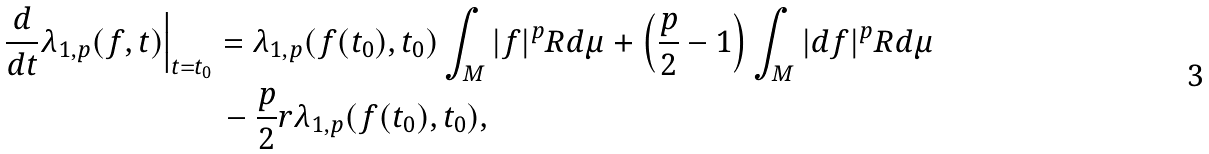Convert formula to latex. <formula><loc_0><loc_0><loc_500><loc_500>\frac { d } { d t } \lambda _ { 1 , p } ( f , t ) \Big | _ { t = t _ { 0 } } & = \lambda _ { 1 , p } ( f ( t _ { 0 } ) , t _ { 0 } ) \int _ { M } | f | ^ { p } R d \mu + \left ( \frac { p } { 2 } - 1 \right ) \int _ { M } | d f | ^ { p } R d \mu \\ & \, - \frac { p } { 2 } r \lambda _ { 1 , p } ( f ( t _ { 0 } ) , t _ { 0 } ) ,</formula> 